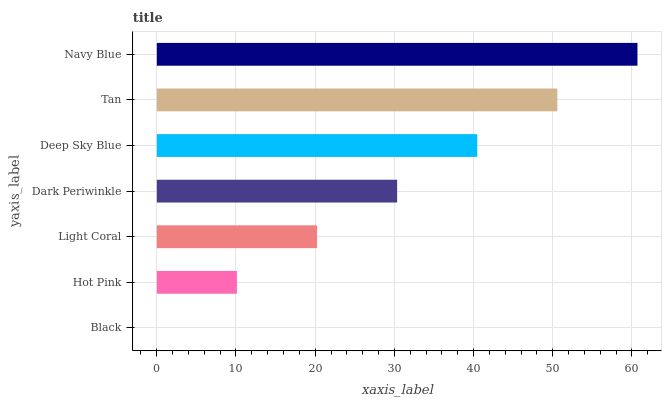Is Black the minimum?
Answer yes or no. Yes. Is Navy Blue the maximum?
Answer yes or no. Yes. Is Hot Pink the minimum?
Answer yes or no. No. Is Hot Pink the maximum?
Answer yes or no. No. Is Hot Pink greater than Black?
Answer yes or no. Yes. Is Black less than Hot Pink?
Answer yes or no. Yes. Is Black greater than Hot Pink?
Answer yes or no. No. Is Hot Pink less than Black?
Answer yes or no. No. Is Dark Periwinkle the high median?
Answer yes or no. Yes. Is Dark Periwinkle the low median?
Answer yes or no. Yes. Is Navy Blue the high median?
Answer yes or no. No. Is Black the low median?
Answer yes or no. No. 